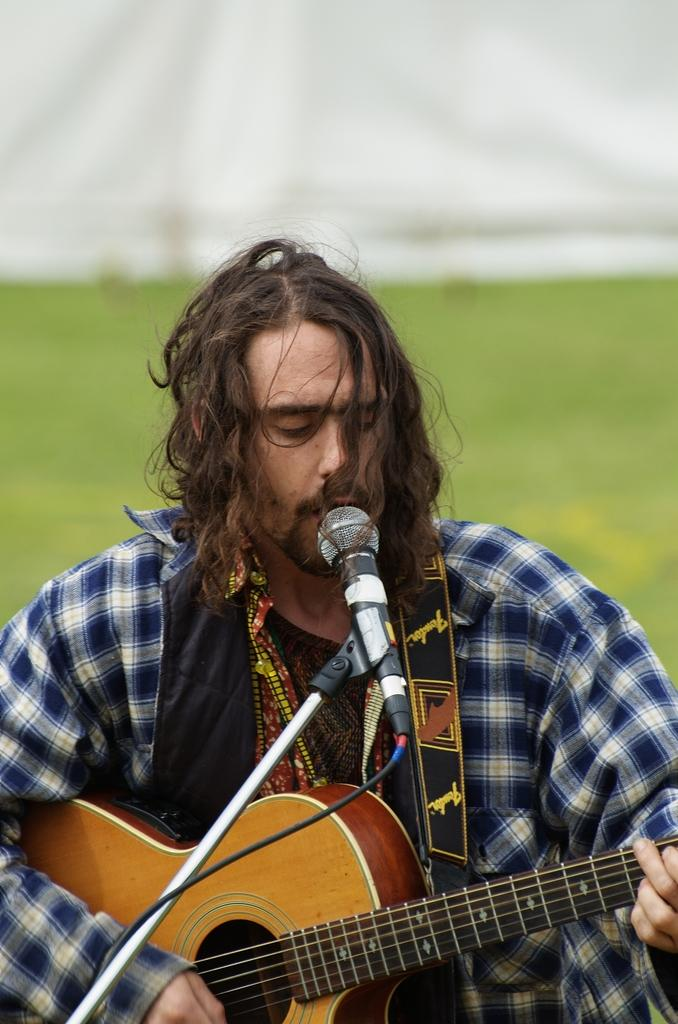What is the person in the image doing? The person is playing a guitar and singing. How is the person holding the guitar? The person is holding the guitar in their hands. What can be seen in the background of the image? There is a greenery part visible in the background. How does the person's nerve affect their ability to play the guitar in the image? There is no information about the person's nerve in the image, so it cannot be determined how it affects their ability to play the guitar. 